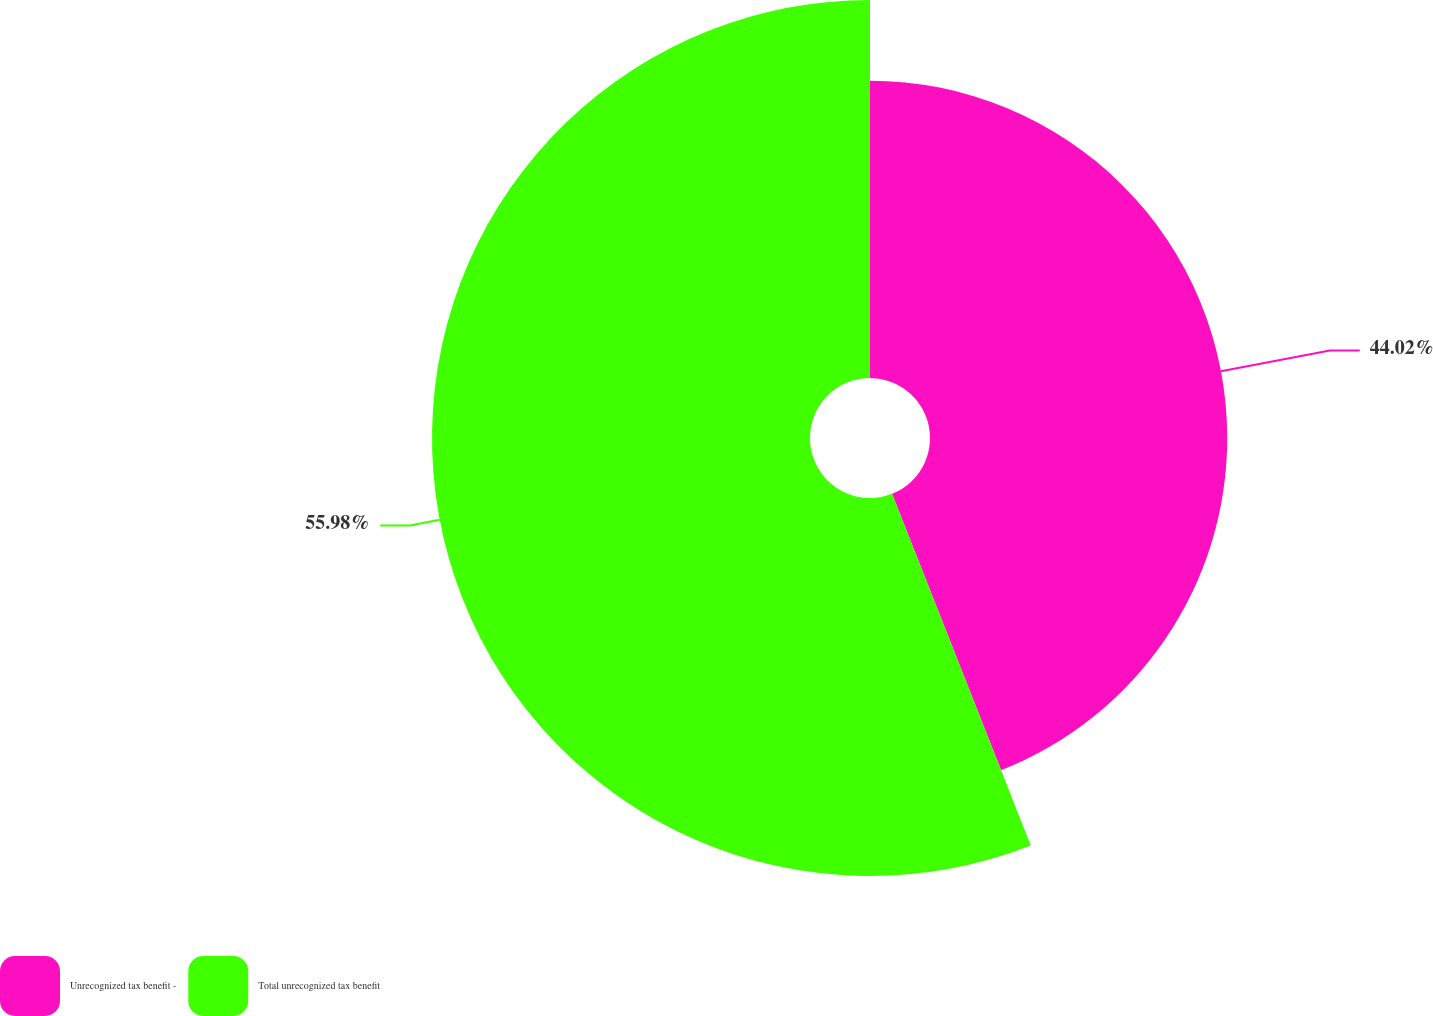<chart> <loc_0><loc_0><loc_500><loc_500><pie_chart><fcel>Unrecognized tax benefit -<fcel>Total unrecognized tax benefit<nl><fcel>44.02%<fcel>55.98%<nl></chart> 